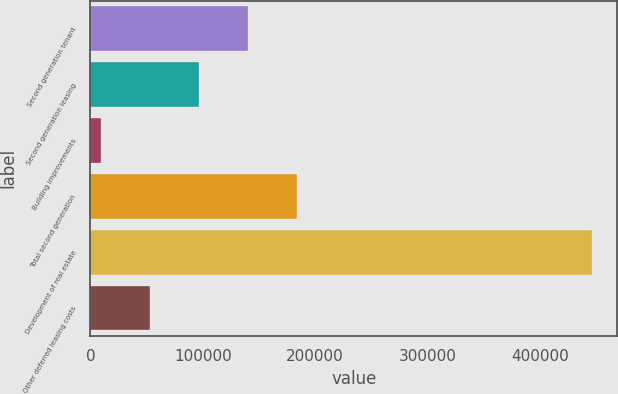Convert chart. <chart><loc_0><loc_0><loc_500><loc_500><bar_chart><fcel>Second generation tenant<fcel>Second generation leasing<fcel>Building improvements<fcel>Total second generation<fcel>Development of real estate<fcel>Other deferred leasing costs<nl><fcel>140473<fcel>96723.6<fcel>9224<fcel>184223<fcel>446722<fcel>52973.8<nl></chart> 